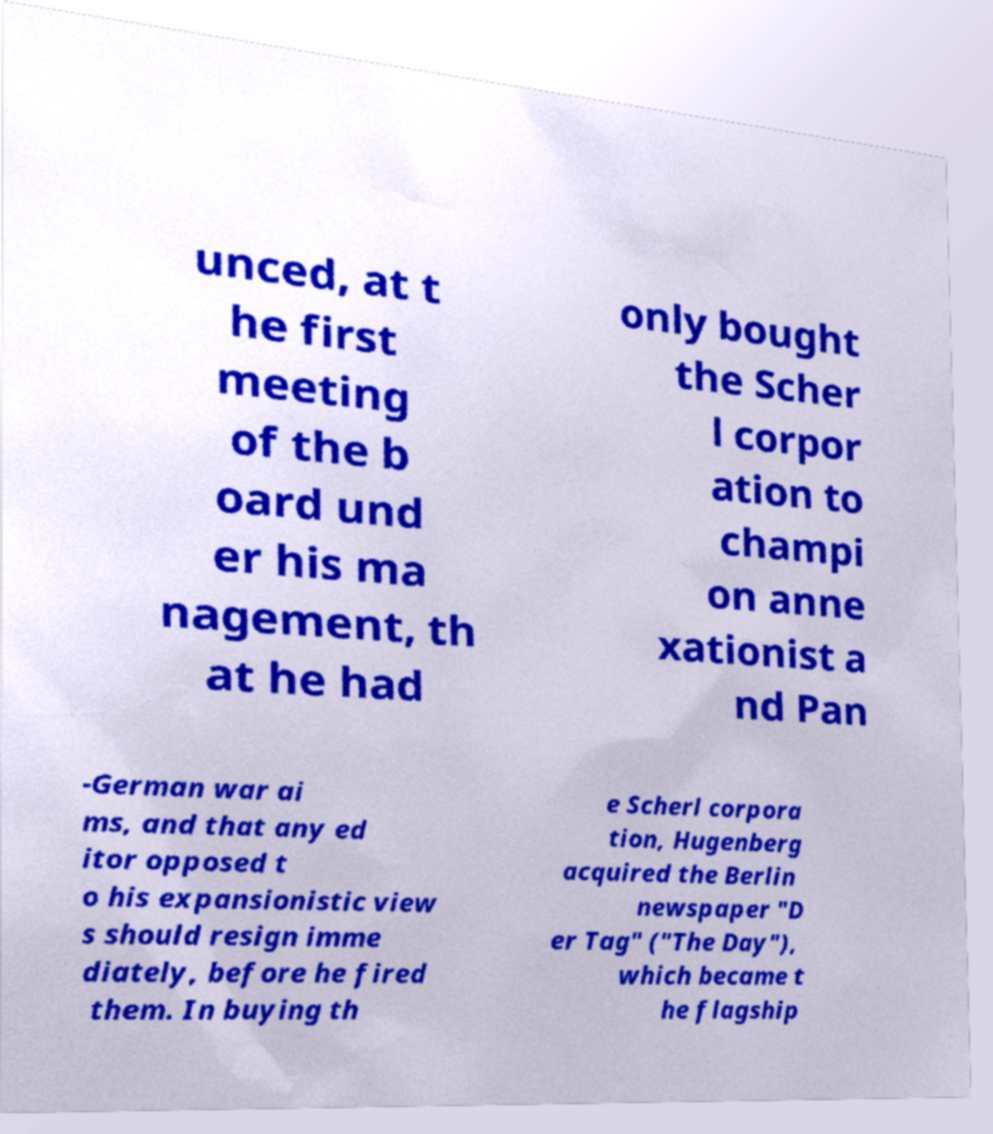Can you read and provide the text displayed in the image?This photo seems to have some interesting text. Can you extract and type it out for me? unced, at t he first meeting of the b oard und er his ma nagement, th at he had only bought the Scher l corpor ation to champi on anne xationist a nd Pan -German war ai ms, and that any ed itor opposed t o his expansionistic view s should resign imme diately, before he fired them. In buying th e Scherl corpora tion, Hugenberg acquired the Berlin newspaper "D er Tag" ("The Day"), which became t he flagship 